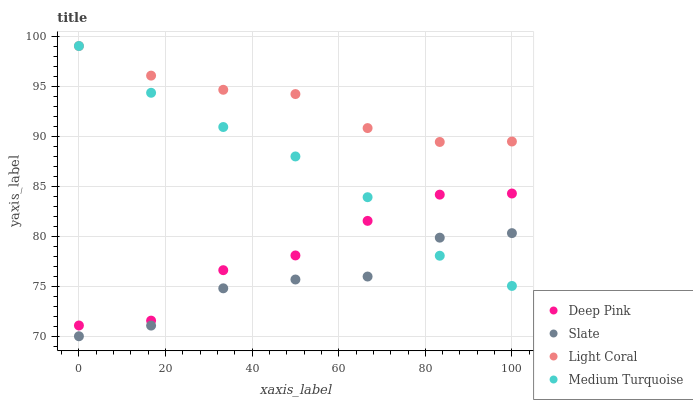Does Slate have the minimum area under the curve?
Answer yes or no. Yes. Does Light Coral have the maximum area under the curve?
Answer yes or no. Yes. Does Deep Pink have the minimum area under the curve?
Answer yes or no. No. Does Deep Pink have the maximum area under the curve?
Answer yes or no. No. Is Medium Turquoise the smoothest?
Answer yes or no. Yes. Is Deep Pink the roughest?
Answer yes or no. Yes. Is Slate the smoothest?
Answer yes or no. No. Is Slate the roughest?
Answer yes or no. No. Does Slate have the lowest value?
Answer yes or no. Yes. Does Deep Pink have the lowest value?
Answer yes or no. No. Does Medium Turquoise have the highest value?
Answer yes or no. Yes. Does Deep Pink have the highest value?
Answer yes or no. No. Is Slate less than Deep Pink?
Answer yes or no. Yes. Is Deep Pink greater than Slate?
Answer yes or no. Yes. Does Deep Pink intersect Medium Turquoise?
Answer yes or no. Yes. Is Deep Pink less than Medium Turquoise?
Answer yes or no. No. Is Deep Pink greater than Medium Turquoise?
Answer yes or no. No. Does Slate intersect Deep Pink?
Answer yes or no. No. 